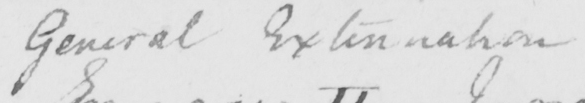What does this handwritten line say? General Extenuation 